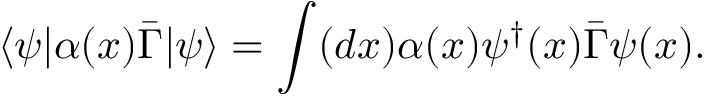Convert formula to latex. <formula><loc_0><loc_0><loc_500><loc_500>\langle \psi | \alpha ( x ) \bar { \Gamma } | \psi \rangle = \int ( d x ) \alpha ( x ) \psi ^ { \dagger } ( x ) \bar { \Gamma } \psi ( x ) .</formula> 